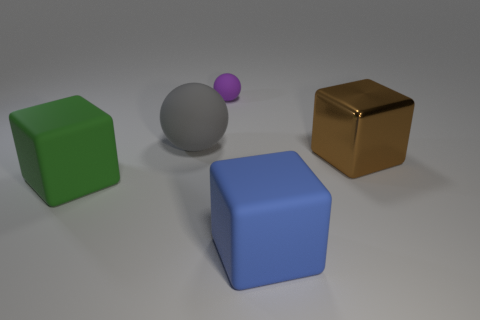Can you describe the lighting in the image and the effect it has on the objects? The lighting in the image appears to be soft and diffused, coming from the upper left side, casting subtle shadows on the right sides of the objects. It creates a calm atmosphere and gives the objects a slightly three-dimensional look without harsh contrasts. 